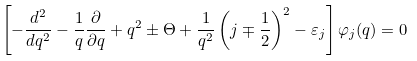Convert formula to latex. <formula><loc_0><loc_0><loc_500><loc_500>\left [ - \frac { d ^ { 2 } } { d q ^ { 2 } } - \frac { 1 } { q } \frac { \partial } { \partial q } + q ^ { 2 } \pm \Theta + \frac { 1 } { q ^ { 2 } } \left ( j \mp \frac { 1 } { 2 } \right ) ^ { 2 } - \varepsilon _ { j } \right ] \varphi _ { j } ( q ) = 0</formula> 